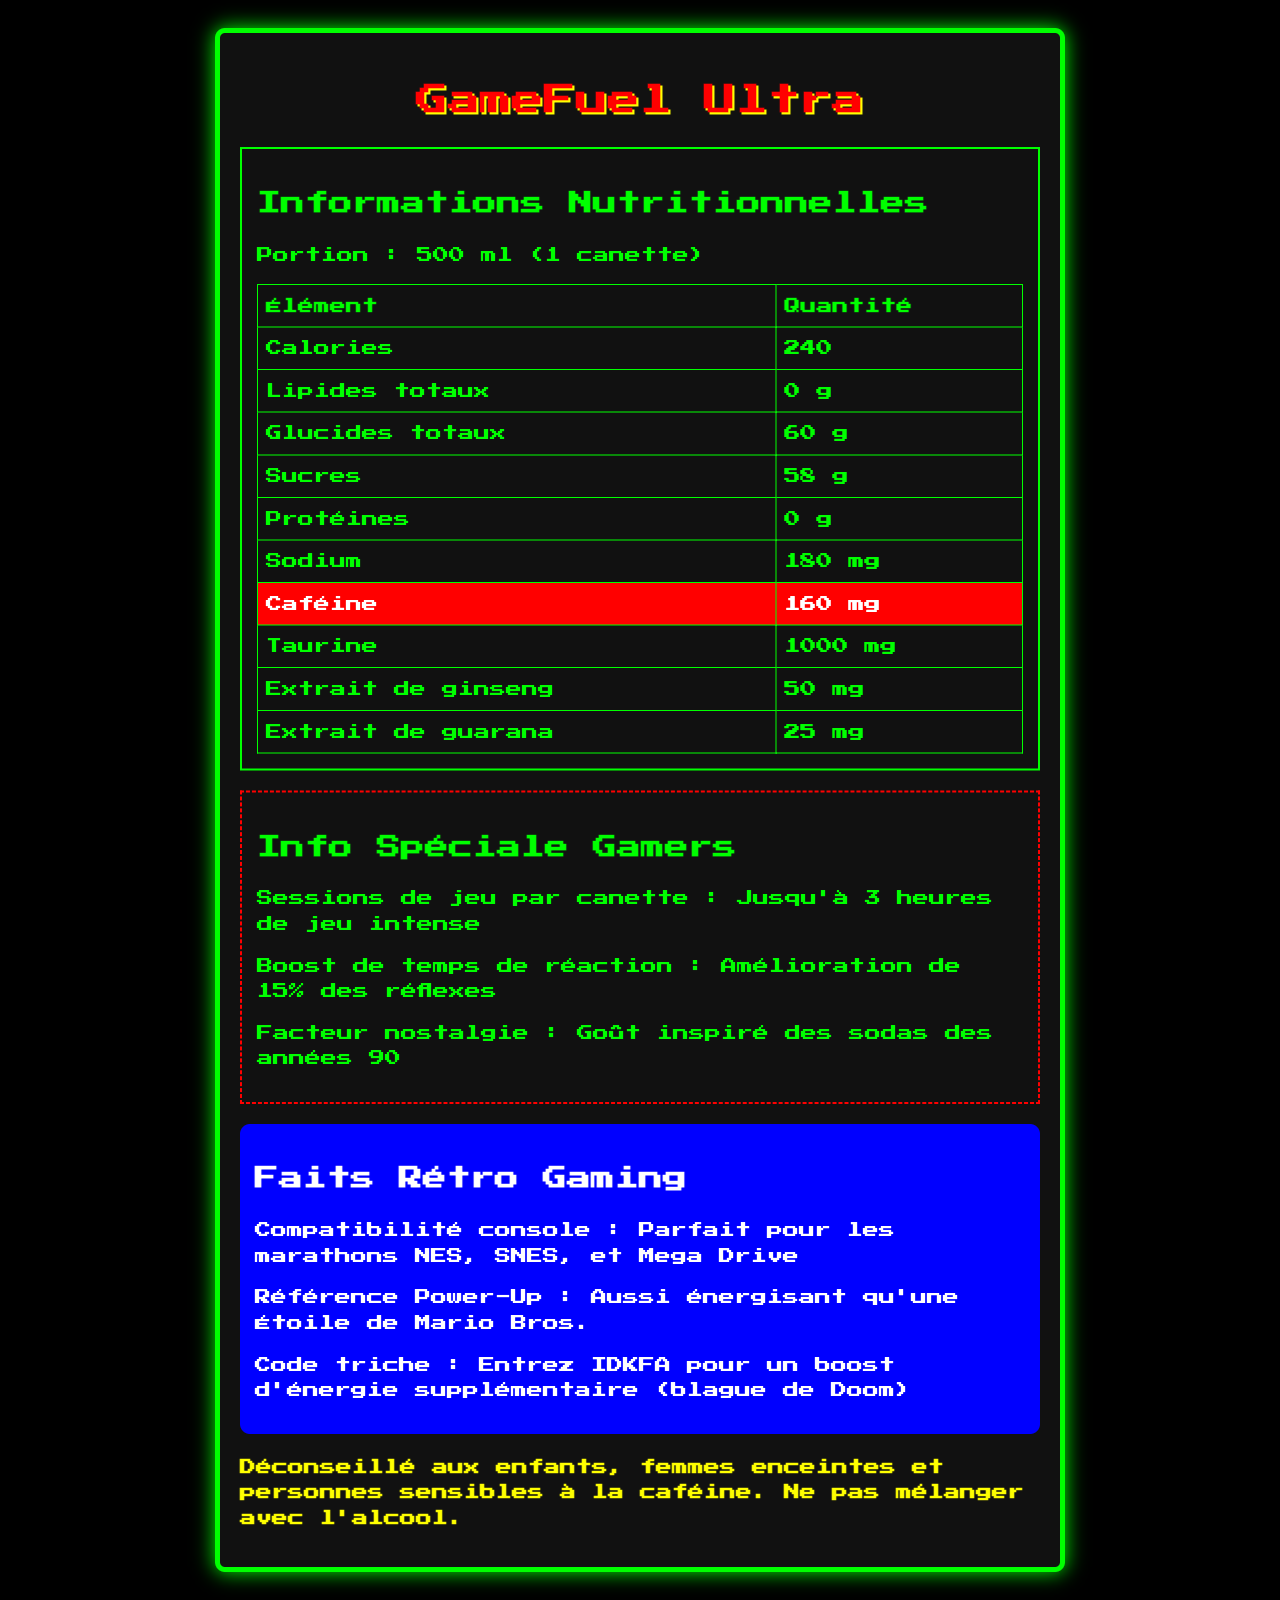What is the serving size of GameFuel Ultra? The document states that the serving size is 500 ml, which corresponds to one can.
Answer: 500 ml (1 canette) How many calories are there in one can of GameFuel Ultra? The document lists the calorie content under the nutritional information section as 240 calories per serving.
Answer: 240 calories What is the total carbohydrate content per serving? According to the nutritional facts, total carbohydrates are listed as 60 grams per serving.
Answer: 60 g What is the amount of caffeine in GameFuel Ultra? The caffeine content is highlighted in the table with nutritional facts, showing it contains 160 mg of caffeine.
Answer: 160 mg How much taurine is in one can? The document lists the taurine content in the nutritional facts section as 1000 mg per can.
Answer: 1000 mg Which vitamin is provided at 2 mg per can? A. Vitamin D B. Vitamin B6 C. Niacin The document specifies that each can contains 2 mg of Vitamin B6, while Vitamin D is 0 mcg, and Niacin is 20 mg.
Answer: B How many servings are there per container? The document states that there is 1 serving per container.
Answer: 1 What is the recommended maximum gaming session duration for one can? In the gamer-specific information section, it mentions that one can support up to 3 hours of intense gaming.
Answer: Jusqu'à 3 heures de jeu intense Is it safe for children to consume GameFuel Ultra? The warning at the bottom of the document states that it is not recommended for children.
Answer: No What is the nostalgic flavor inspired by? A. Modern energy drinks B. Sodas from the 90s C. Herbal teas The document's gamer-specific section mentions that the nostalgia factor is inspired by the taste of sodas from the 90s.
Answer: B Which mineral does GameFuel Ultra contain the most? A. Sodium B. Potassium C. Calcium The nutritional table shows sodium content as 180 mg, potassium as 80 mg, and calcium as 0 mg; thus, sodium is the highest.
Answer: A Summarize the main features of GameFuel Ultra. GameFuel Ultra serves as an energy-boosting drink meant to enhance gaming sessions by improving reflexes and offering a nostalgic taste, while containing significant amounts of caffeine and taurine.
Answer: GameFuel Ultra is an energy drink designed for gamers, providing 240 calories and 160 mg of caffeine per 500 ml can. It boasts 60 grams of total carbohydrates and 1000 mg of taurine. The drink is said to enhance gaming performance for up to 3 hours with a 15% reaction time boost and has a nostalgic flavor inspired by 90s sodas. It is not recommended for children, pregnant women, or those sensitive to caffeine. How does GameFuel Ultra improve reaction time? The gamer-specific information section mentions that it offers a 15% improvement in reflexes.
Answer: Amélioration de 15% des réflexes What special info is provided for retro gaming fans? In the "Retro Gaming Facts" section, the document lists compatibility with iconic retro consoles and fun references related to gaming culture.
Answer: Console compatibility with NES, SNES, Mega Drive; Power-Up reference as energizing as a Mario Bros Star; A cheat code joke IDKFA from Doom Can you determine the ingredients of GameFuel Ultra? The document does not provide a specific ingredient list, only highlighting the nutritional content and certain components like caffeine and taurine.
Answer: Not enough information 